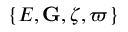<formula> <loc_0><loc_0><loc_500><loc_500>\{ E , { G } , \zeta , \varpi \}</formula> 